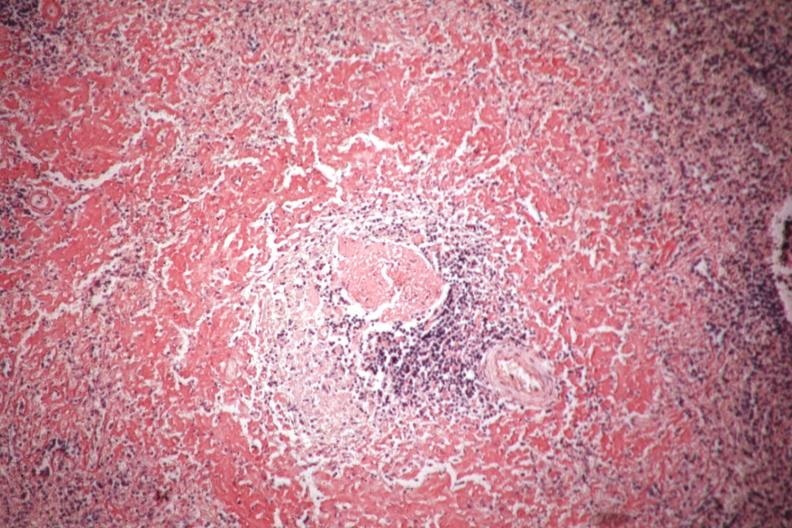what does this image show?
Answer the question using a single word or phrase. Congo red well shown perifollicular amyloid 